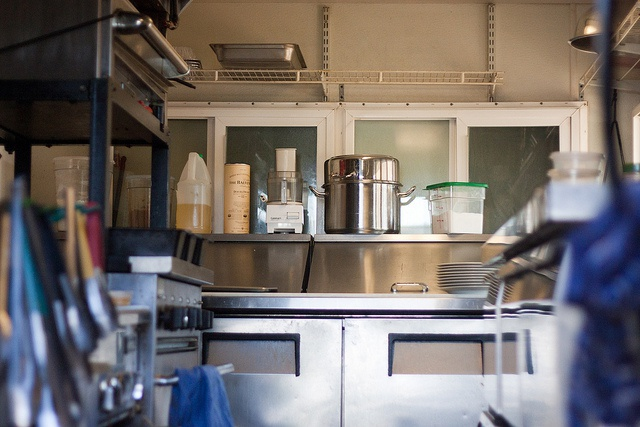Describe the objects in this image and their specific colors. I can see oven in black and gray tones, bottle in black, tan, darkgray, gray, and olive tones, bowl in black, darkgray, and lightgray tones, and bowl in black, darkgray, lightgray, and gray tones in this image. 